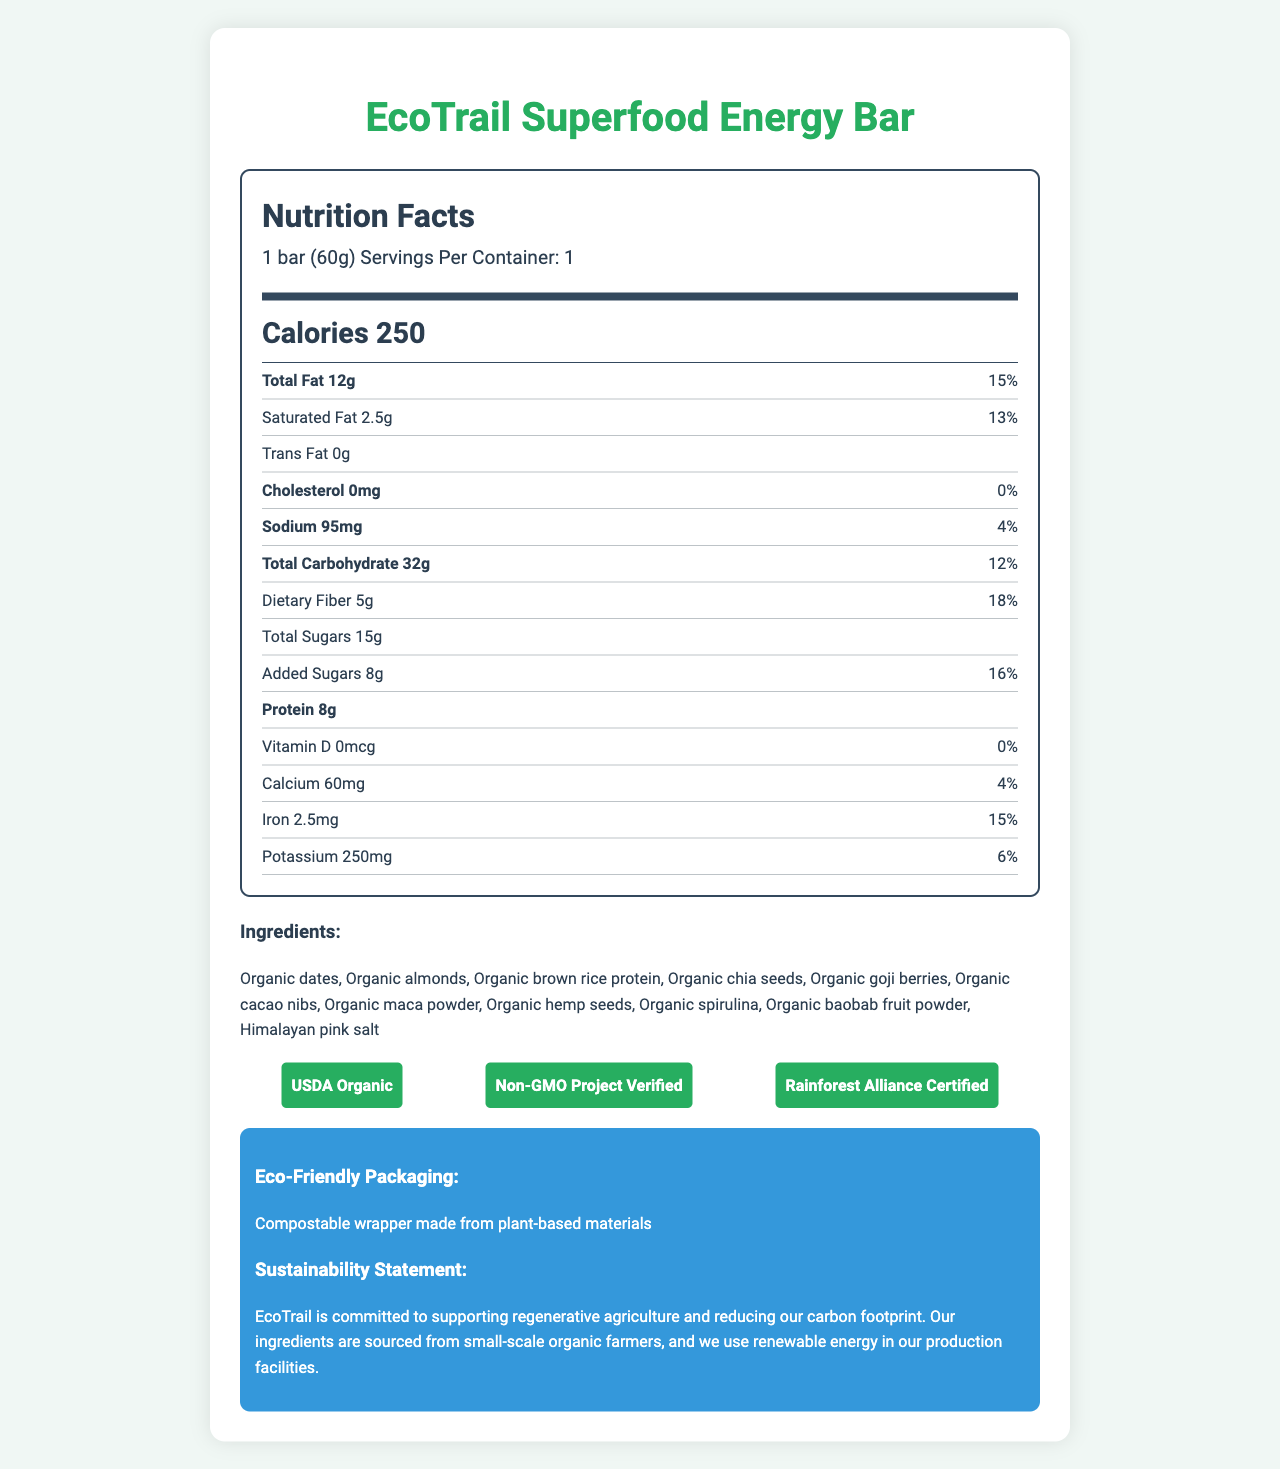how many calories are in one serving? The label states that there are 250 calories in one EcoTrail Superfood Energy Bar, which is the serving size.
Answer: 250 how much protein is in the energy bar? The protein content per serving is listed as 8 grams on the nutrition label.
Answer: 8g does the EcoTrail Superfood Energy Bar contain any cholesterol? The label specifies that the cholesterol content is 0mg, which means the bar contains no cholesterol.
Answer: No name three ingredients listed in the EcoTrail Superfood Energy Bar? These three ingredients are among those listed on the label.
Answer: Organic dates, Organic almonds, Organic chia seeds what percentage of daily value (%DV) for iron does the energy bar provide? The label shows that the iron content is 2.5mg, which is 15% of the daily value.
Answer: 15% which certification is NOT mentioned on the label? A. USDA Organic B. Non-GMO Project Verified C. Fair Trade Certified D. Rainforest Alliance Certified The certifications mentioned are USDA Organic, Non-GMO Project Verified, and Rainforest Alliance Certified. Fair Trade Certified is not listed.
Answer: C. Fair Trade Certified how much dietary fiber is in one bar? The nutrition label states that each bar contains 5 grams of dietary fiber, which is 18% of the daily value.
Answer: 5g is the energy bar suitable for vegans? The label includes "Vegan" under the special features, indicating that the bar is suitable for vegans.
Answer: Yes what kind of packaging does the EcoTrail Superfood Energy Bar use? A. Plastic B. Recyclable C. Compostable D. Biodegradable The eco-friendly packaging is described as a "Compostable wrapper made from plant-based materials."
Answer: C. Compostable how should the energy bar be stored? The storage instructions on the label recommend keeping the bar in a cool, dry place, away from direct sunlight and extreme temperatures.
Answer: Store in a cool, dry place. Avoid direct sunlight and extreme temperatures. how much sodium is in a serving of the energy bar? The nutrition label lists the sodium content as 95mg, which is 4% of the daily value.
Answer: 95mg how are the ingredients sourced for the EcoTrail Superfood Energy Bar? The sustainability statement on the label mentions that the ingredients are sourced from small-scale organic farmers.
Answer: From small-scale organic farmers what is the recommended use of the energy bar? The label suggests consuming the bar before or during physical activity for sustained energy, making it ideal for hikers, climbers, and outdoor enthusiasts.
Answer: Perfect for hikers, climbers, and outdoor enthusiasts. Consume before or during physical activity for sustained energy. are there any traces of peanuts in the EcoTrail Superfood Energy Bar? The allergen information specifies that the energy bar contains almonds and may contain traces of other tree nuts and peanuts.
Answer: May contain traces of other tree nuts and peanuts how much added sugar does the energy bar contain? The label indicates that there are 8 grams of added sugars in one serving, which is 16% of the daily value.
Answer: 8g describe the main idea of the EcoTrail Superfood Energy Bar nutrition label. The label includes comprehensive details about the nutritional content and benefits of the energy bar, emphasizing its health-conscious and eco-friendly attributes.
Answer: The EcoTrail Superfood Energy Bar nutrition label provides detailed information about the serving size, calorie content, various nutrients, ingredients, certifications, eco-friendly packaging, special features, recommended use, storage instructions, and sustainability statement. It highlights that the bar is organic, vegan, gluten-free, with no artificial preservatives, flavors, or colors, and is specifically designed for outdoor enthusiasts. what is the cost of one EcoTrail Superfood Energy Bar? The label provides detailed nutritional and ingredient information but does not mention the cost of the bar.
Answer: Cannot be determined 